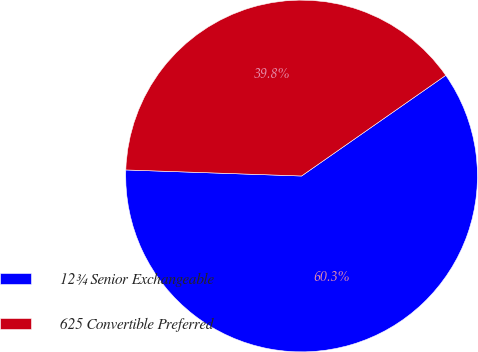<chart> <loc_0><loc_0><loc_500><loc_500><pie_chart><fcel>12¾ Senior Exchangeable<fcel>625 Convertible Preferred<nl><fcel>60.25%<fcel>39.75%<nl></chart> 